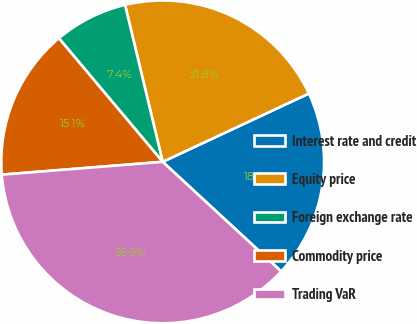<chart> <loc_0><loc_0><loc_500><loc_500><pie_chart><fcel>Interest rate and credit<fcel>Equity price<fcel>Foreign exchange rate<fcel>Commodity price<fcel>Trading VaR<nl><fcel>18.84%<fcel>21.79%<fcel>7.37%<fcel>15.15%<fcel>36.86%<nl></chart> 